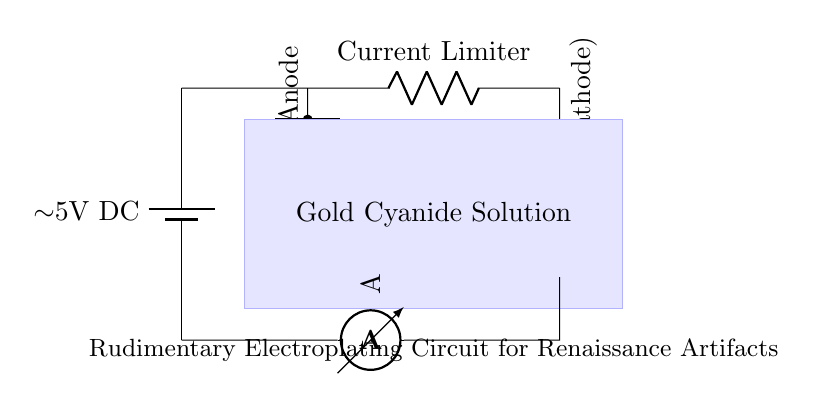What type of solution is used in this circuit? The circuit diagram labels the solution as "Gold Cyanide Solution," indicating that it is specifically used for the electroplating process.
Answer: Gold Cyanide Solution What is the purpose of the gold anode in the circuit? The gold anode serves as the source of gold ions, which are deposited onto the cathode (artifact) during the electroplating process.
Answer: Source of gold ions What component limits the current in this electroplating circuit? The circuit includes a resistor labeled "Current Limiter," which restricts the flow of electric current to ensure the plating occurs correctly.
Answer: Current Limiter What is the voltage supplied by the power source? The power source is indicated as a "5V DC" battery, providing a direct current voltage of 5 volts to the circuit.
Answer: 5V What role does the cathode play in this electroplating circuit? The cathode is identified as the "Artifact," which is the object being plated with gold; it attracts gold ions from the solution and receives the metallic layer.
Answer: Artifact How does the current flow in this circuit? The current flows from the power source to the gold anode, through the electrolyte solution, and then to the artifact acting as the cathode, following the circuit path shown.
Answer: From power source to anode to cathode Which component in the circuit measures the current? An ammeter is included in the circuit specifically to measure the amount of electric current flowing through it.
Answer: Ammeter 